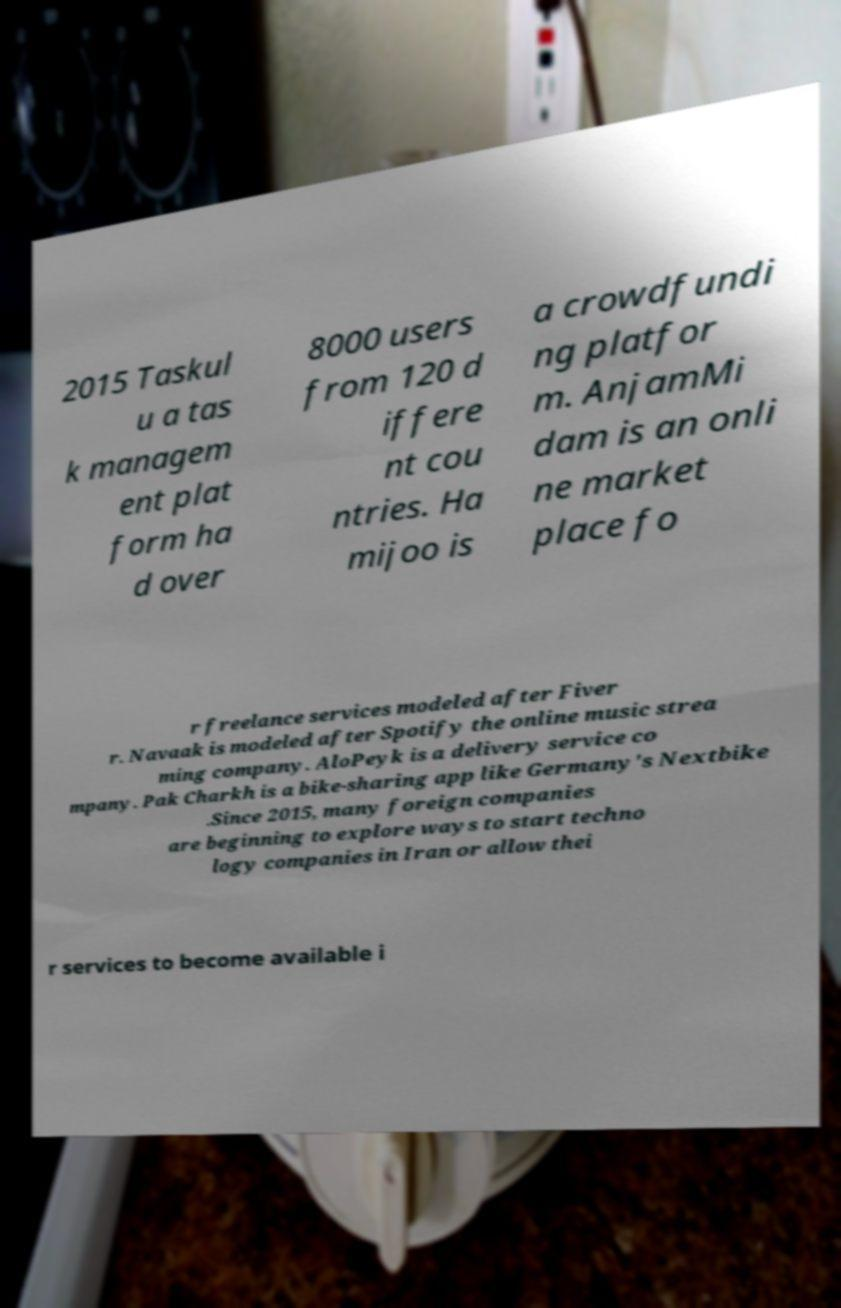For documentation purposes, I need the text within this image transcribed. Could you provide that? 2015 Taskul u a tas k managem ent plat form ha d over 8000 users from 120 d iffere nt cou ntries. Ha mijoo is a crowdfundi ng platfor m. AnjamMi dam is an onli ne market place fo r freelance services modeled after Fiver r. Navaak is modeled after Spotify the online music strea ming company. AloPeyk is a delivery service co mpany. Pak Charkh is a bike-sharing app like Germany's Nextbike .Since 2015, many foreign companies are beginning to explore ways to start techno logy companies in Iran or allow thei r services to become available i 